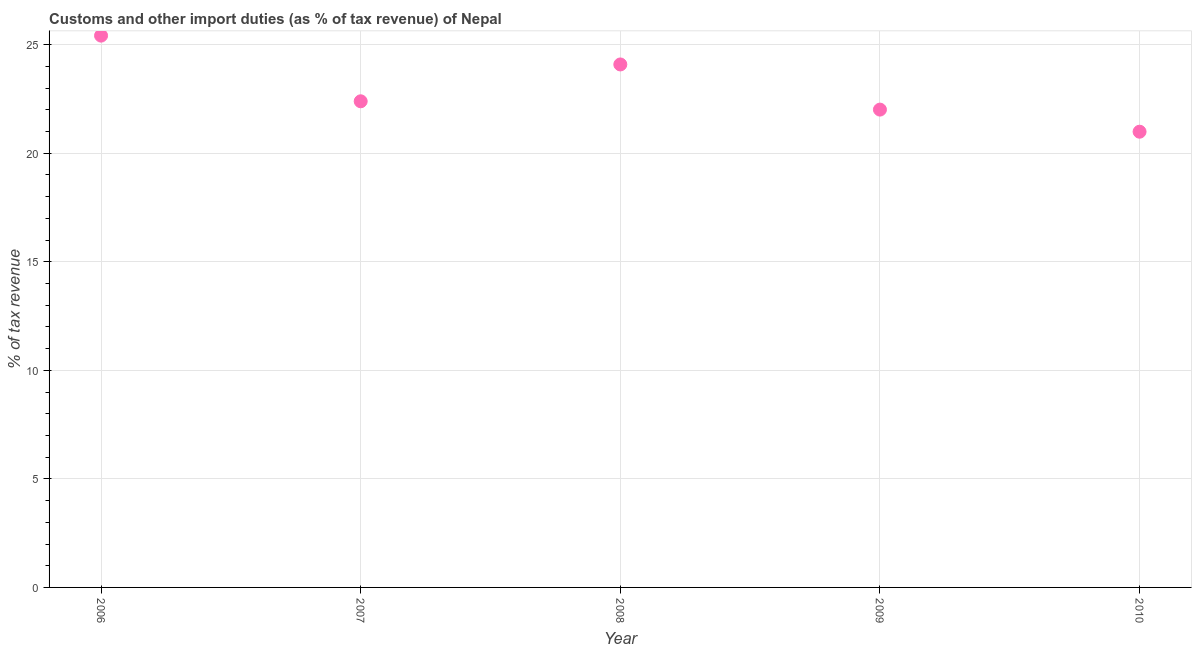What is the customs and other import duties in 2010?
Give a very brief answer. 20.99. Across all years, what is the maximum customs and other import duties?
Offer a terse response. 25.42. Across all years, what is the minimum customs and other import duties?
Make the answer very short. 20.99. In which year was the customs and other import duties maximum?
Ensure brevity in your answer.  2006. What is the sum of the customs and other import duties?
Offer a very short reply. 114.91. What is the difference between the customs and other import duties in 2006 and 2008?
Provide a short and direct response. 1.33. What is the average customs and other import duties per year?
Provide a succinct answer. 22.98. What is the median customs and other import duties?
Offer a terse response. 22.39. In how many years, is the customs and other import duties greater than 10 %?
Offer a terse response. 5. What is the ratio of the customs and other import duties in 2008 to that in 2009?
Offer a terse response. 1.09. Is the difference between the customs and other import duties in 2007 and 2010 greater than the difference between any two years?
Provide a succinct answer. No. What is the difference between the highest and the second highest customs and other import duties?
Provide a short and direct response. 1.33. Is the sum of the customs and other import duties in 2006 and 2007 greater than the maximum customs and other import duties across all years?
Provide a short and direct response. Yes. What is the difference between the highest and the lowest customs and other import duties?
Your answer should be compact. 4.43. Does the customs and other import duties monotonically increase over the years?
Your answer should be compact. No. How many years are there in the graph?
Keep it short and to the point. 5. What is the difference between two consecutive major ticks on the Y-axis?
Provide a short and direct response. 5. Are the values on the major ticks of Y-axis written in scientific E-notation?
Make the answer very short. No. Does the graph contain any zero values?
Your response must be concise. No. What is the title of the graph?
Keep it short and to the point. Customs and other import duties (as % of tax revenue) of Nepal. What is the label or title of the X-axis?
Offer a terse response. Year. What is the label or title of the Y-axis?
Provide a short and direct response. % of tax revenue. What is the % of tax revenue in 2006?
Provide a succinct answer. 25.42. What is the % of tax revenue in 2007?
Give a very brief answer. 22.39. What is the % of tax revenue in 2008?
Your answer should be very brief. 24.09. What is the % of tax revenue in 2009?
Your answer should be very brief. 22.01. What is the % of tax revenue in 2010?
Offer a very short reply. 20.99. What is the difference between the % of tax revenue in 2006 and 2007?
Offer a very short reply. 3.02. What is the difference between the % of tax revenue in 2006 and 2008?
Ensure brevity in your answer.  1.33. What is the difference between the % of tax revenue in 2006 and 2009?
Your answer should be compact. 3.41. What is the difference between the % of tax revenue in 2006 and 2010?
Give a very brief answer. 4.43. What is the difference between the % of tax revenue in 2007 and 2008?
Offer a terse response. -1.7. What is the difference between the % of tax revenue in 2007 and 2009?
Offer a very short reply. 0.38. What is the difference between the % of tax revenue in 2007 and 2010?
Ensure brevity in your answer.  1.4. What is the difference between the % of tax revenue in 2008 and 2009?
Your response must be concise. 2.08. What is the difference between the % of tax revenue in 2008 and 2010?
Provide a succinct answer. 3.1. What is the difference between the % of tax revenue in 2009 and 2010?
Provide a succinct answer. 1.02. What is the ratio of the % of tax revenue in 2006 to that in 2007?
Your response must be concise. 1.14. What is the ratio of the % of tax revenue in 2006 to that in 2008?
Provide a short and direct response. 1.05. What is the ratio of the % of tax revenue in 2006 to that in 2009?
Offer a terse response. 1.16. What is the ratio of the % of tax revenue in 2006 to that in 2010?
Keep it short and to the point. 1.21. What is the ratio of the % of tax revenue in 2007 to that in 2008?
Provide a succinct answer. 0.93. What is the ratio of the % of tax revenue in 2007 to that in 2009?
Your answer should be compact. 1.02. What is the ratio of the % of tax revenue in 2007 to that in 2010?
Make the answer very short. 1.07. What is the ratio of the % of tax revenue in 2008 to that in 2009?
Your answer should be very brief. 1.09. What is the ratio of the % of tax revenue in 2008 to that in 2010?
Your answer should be compact. 1.15. What is the ratio of the % of tax revenue in 2009 to that in 2010?
Offer a very short reply. 1.05. 